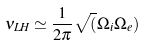<formula> <loc_0><loc_0><loc_500><loc_500>\nu _ { L H } \simeq \frac { 1 } { 2 \pi } \sqrt { ( } \Omega _ { i } \Omega _ { e } )</formula> 